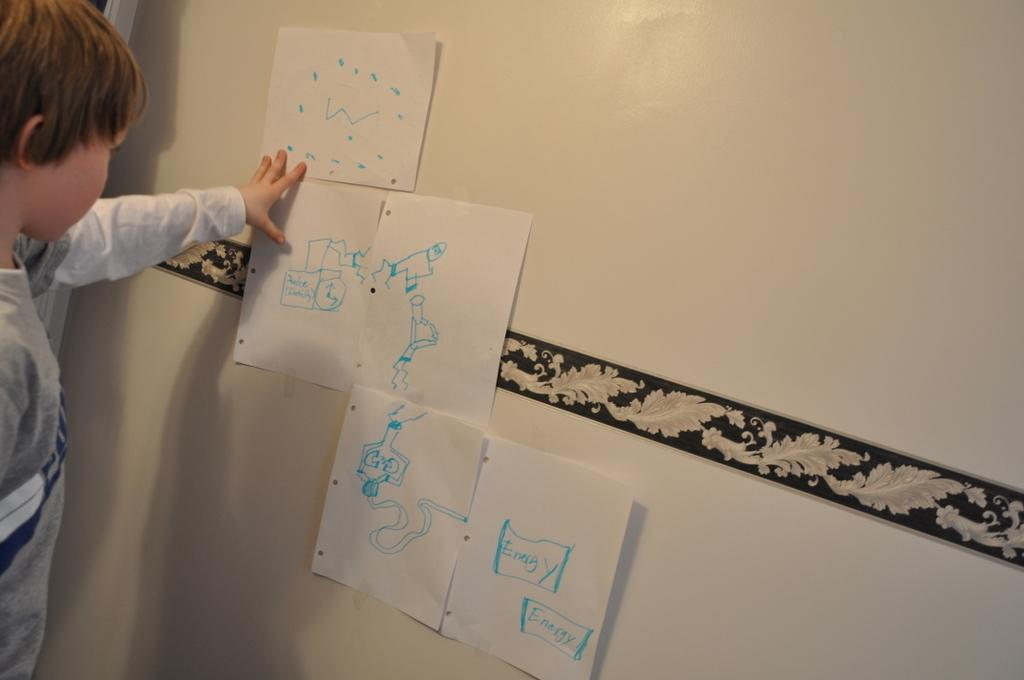<image>
Write a terse but informative summary of the picture. A young boy using drawing is demonstrating energy. 